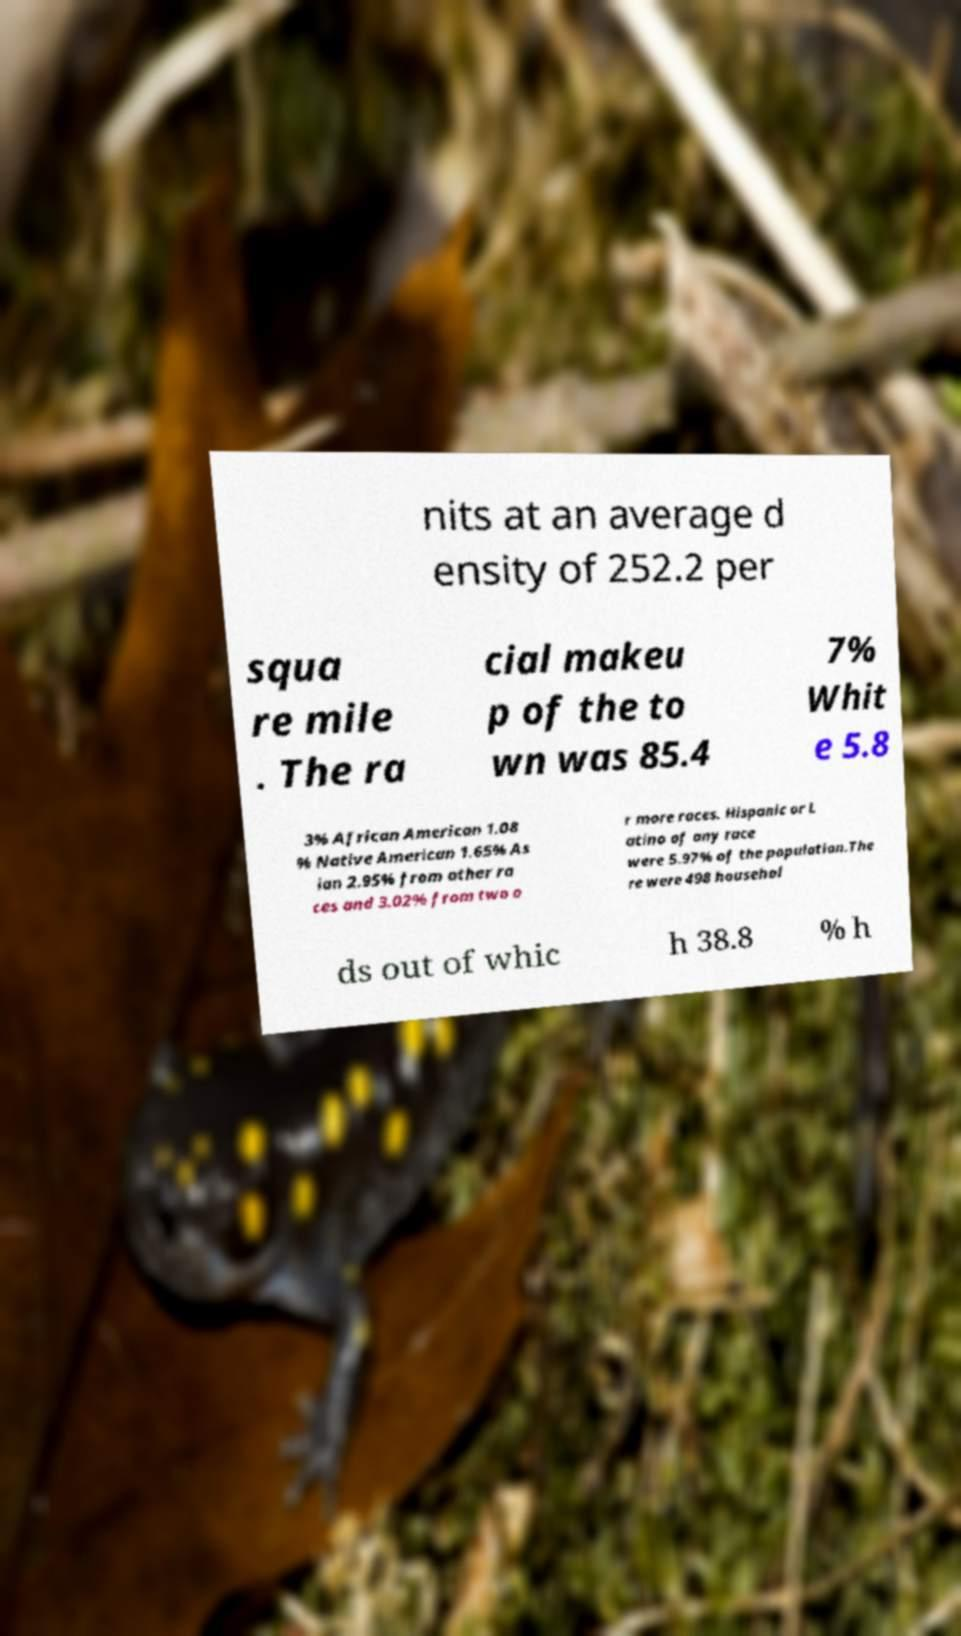Could you assist in decoding the text presented in this image and type it out clearly? nits at an average d ensity of 252.2 per squa re mile . The ra cial makeu p of the to wn was 85.4 7% Whit e 5.8 3% African American 1.08 % Native American 1.65% As ian 2.95% from other ra ces and 3.02% from two o r more races. Hispanic or L atino of any race were 5.97% of the population.The re were 498 househol ds out of whic h 38.8 % h 